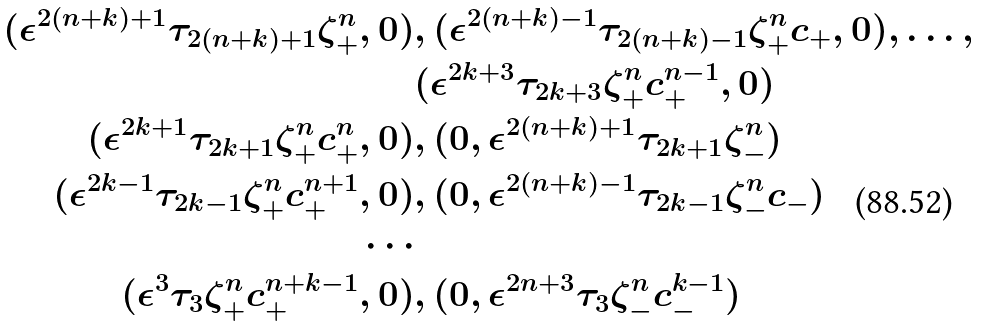<formula> <loc_0><loc_0><loc_500><loc_500>( \epsilon ^ { 2 ( n + k ) + 1 } \tau _ { 2 ( n + k ) + 1 } \zeta _ { + } ^ { n } , 0 ) & , ( \epsilon ^ { 2 ( n + k ) - 1 } \tau _ { 2 ( n + k ) - 1 } \zeta _ { + } ^ { n } c _ { + } , 0 ) , \dots , \\ & ( \epsilon ^ { 2 k + 3 } \tau _ { 2 k + 3 } \zeta _ { + } ^ { n } c _ { + } ^ { n - 1 } , 0 ) \\ ( \epsilon ^ { 2 k + 1 } \tau _ { 2 k + 1 } \zeta _ { + } ^ { n } c _ { + } ^ { n } , 0 ) & , ( 0 , \epsilon ^ { 2 ( n + k ) + 1 } \tau _ { 2 k + 1 } \zeta _ { - } ^ { n } ) \\ ( \epsilon ^ { 2 k - 1 } \tau _ { 2 k - 1 } \zeta _ { + } ^ { n } c _ { + } ^ { n + 1 } , 0 ) & , ( 0 , \epsilon ^ { 2 ( n + k ) - 1 } \tau _ { 2 k - 1 } \zeta _ { - } ^ { n } c _ { - } ) \\ \cdots \\ ( \epsilon ^ { 3 } \tau _ { 3 } \zeta _ { + } ^ { n } c _ { + } ^ { n + k - 1 } , 0 ) & , ( 0 , \epsilon ^ { 2 n + 3 } \tau _ { 3 } \zeta _ { - } ^ { n } c _ { - } ^ { k - 1 } )</formula> 